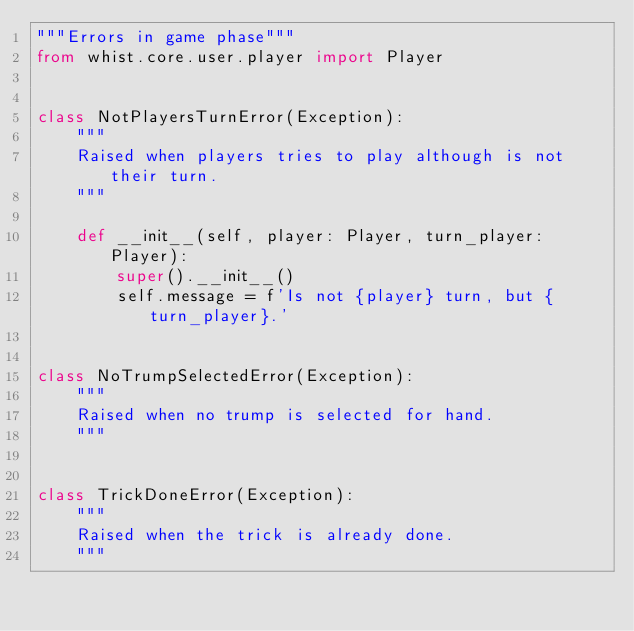<code> <loc_0><loc_0><loc_500><loc_500><_Python_>"""Errors in game phase"""
from whist.core.user.player import Player


class NotPlayersTurnError(Exception):
    """
    Raised when players tries to play although is not their turn.
    """

    def __init__(self, player: Player, turn_player: Player):
        super().__init__()
        self.message = f'Is not {player} turn, but {turn_player}.'


class NoTrumpSelectedError(Exception):
    """
    Raised when no trump is selected for hand.
    """


class TrickDoneError(Exception):
    """
    Raised when the trick is already done.
    """
</code> 